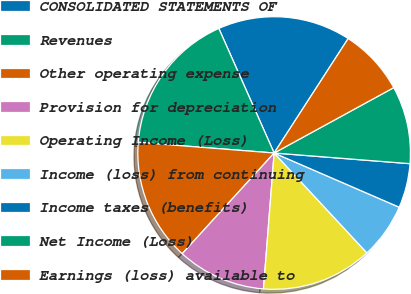<chart> <loc_0><loc_0><loc_500><loc_500><pie_chart><fcel>CONSOLIDATED STATEMENTS OF<fcel>Revenues<fcel>Other operating expense<fcel>Provision for depreciation<fcel>Operating Income (Loss)<fcel>Income (loss) from continuing<fcel>Income taxes (benefits)<fcel>Net Income (Loss)<fcel>Earnings (loss) available to<nl><fcel>15.79%<fcel>17.1%<fcel>14.47%<fcel>10.53%<fcel>13.16%<fcel>6.58%<fcel>5.26%<fcel>9.21%<fcel>7.9%<nl></chart> 